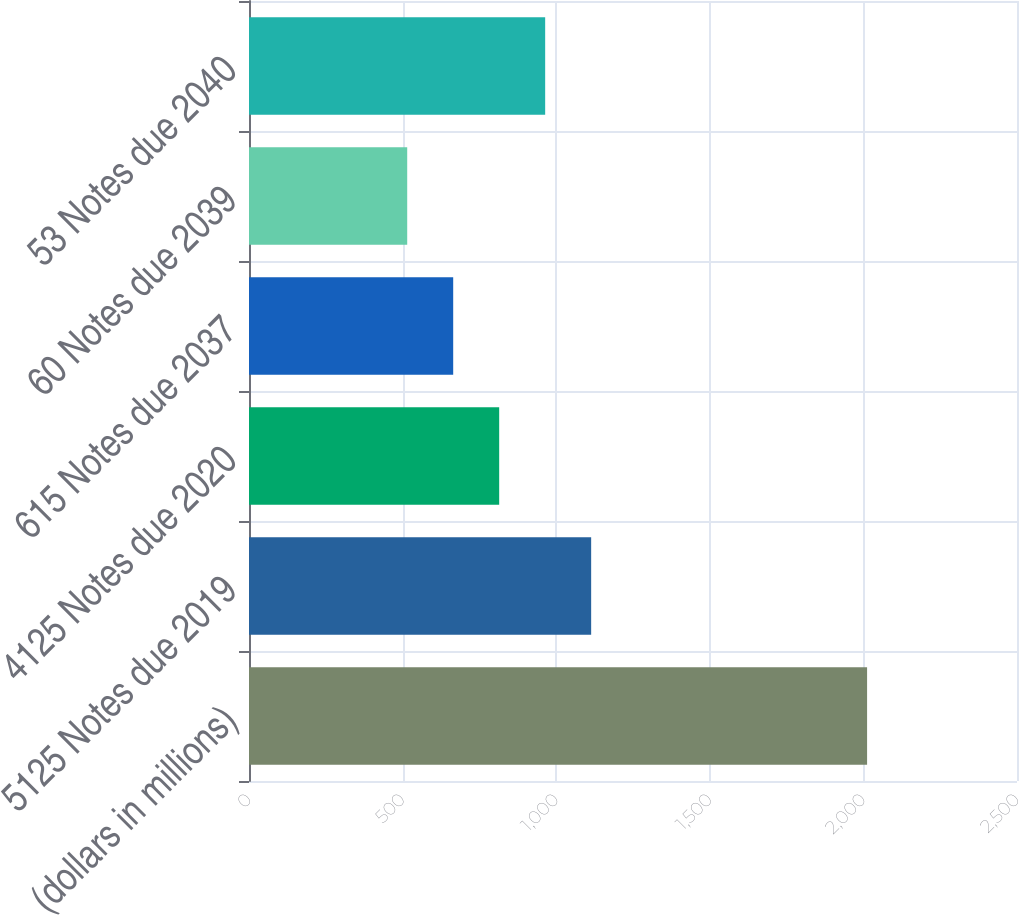Convert chart to OTSL. <chart><loc_0><loc_0><loc_500><loc_500><bar_chart><fcel>(dollars in millions)<fcel>5125 Notes due 2019<fcel>4125 Notes due 2020<fcel>615 Notes due 2037<fcel>60 Notes due 2039<fcel>53 Notes due 2040<nl><fcel>2012<fcel>1113.8<fcel>814.4<fcel>664.7<fcel>515<fcel>964.1<nl></chart> 